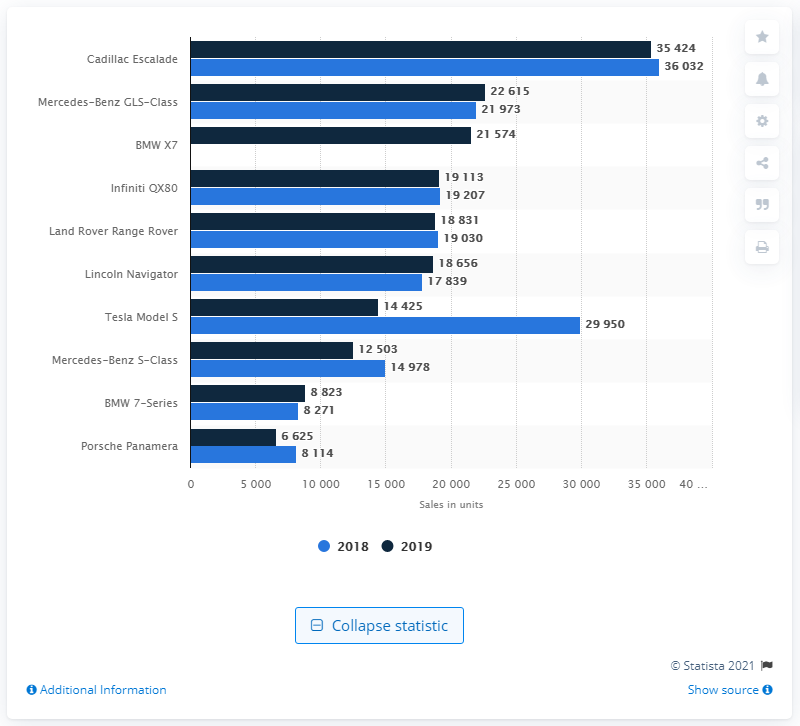Point out several critical features in this image. The sum of the 2018 and 2019 models of the BMW 7-series is 17,094. The Tesla Model S bar for 2018 had a significantly lower value than the value for 2019, indicating that the company's sales for this model were lower in 2019 compared to the previous year. 